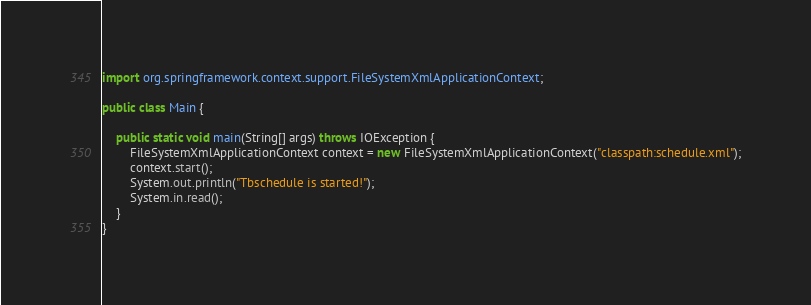<code> <loc_0><loc_0><loc_500><loc_500><_Java_>import org.springframework.context.support.FileSystemXmlApplicationContext;

public class Main {

    public static void main(String[] args) throws IOException {
        FileSystemXmlApplicationContext context = new FileSystemXmlApplicationContext("classpath:schedule.xml");
        context.start();
        System.out.println("Tbschedule is started!");
        System.in.read();
    }
}
</code> 